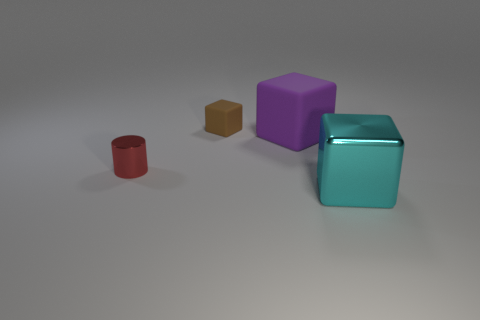Add 2 cyan metal things. How many objects exist? 6 Subtract all cubes. How many objects are left? 1 Subtract all small brown blocks. Subtract all tiny matte blocks. How many objects are left? 2 Add 4 big purple objects. How many big purple objects are left? 5 Add 2 red metal objects. How many red metal objects exist? 3 Subtract 0 blue cubes. How many objects are left? 4 